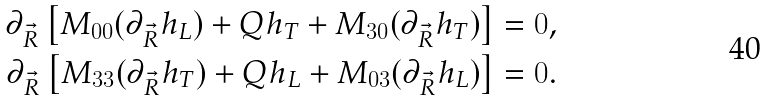<formula> <loc_0><loc_0><loc_500><loc_500>\partial _ { \vec { R } } \left [ M _ { 0 0 } ( \partial _ { \vec { R } } h _ { L } ) + Q h _ { T } + M _ { 3 0 } ( \partial _ { \vec { R } } h _ { T } ) \right ] & = 0 , \\ \partial _ { \vec { R } } \left [ M _ { 3 3 } ( \partial _ { \vec { R } } h _ { T } ) + Q h _ { L } + M _ { 0 3 } ( \partial _ { \vec { R } } h _ { L } ) \right ] & = 0 .</formula> 